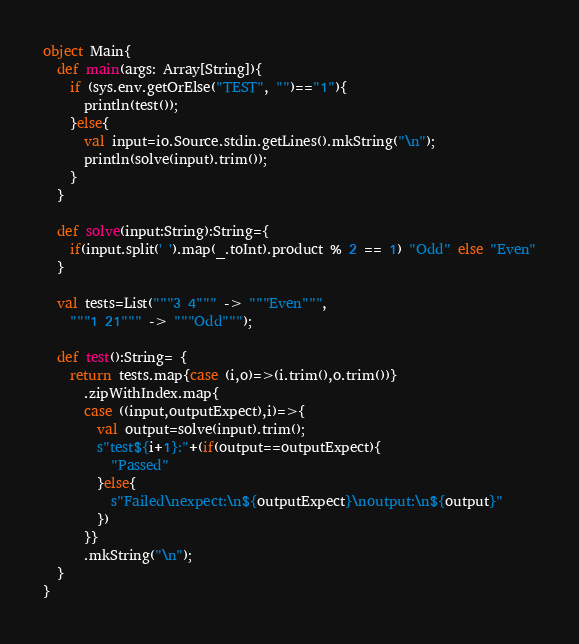<code> <loc_0><loc_0><loc_500><loc_500><_Scala_>object Main{
  def main(args: Array[String]){
    if (sys.env.getOrElse("TEST", "")=="1"){
      println(test());
    }else{
      val input=io.Source.stdin.getLines().mkString("\n");
      println(solve(input).trim());
    }
  }

  def solve(input:String):String={
    if(input.split(' ').map(_.toInt).product % 2 == 1) "Odd" else "Even"
  }

  val tests=List("""3 4""" -> """Even""",
    """1 21""" -> """Odd""");

  def test():String= {
    return tests.map{case (i,o)=>(i.trim(),o.trim())}
      .zipWithIndex.map{
      case ((input,outputExpect),i)=>{
        val output=solve(input).trim();
        s"test${i+1}:"+(if(output==outputExpect){
          "Passed"
        }else{
          s"Failed\nexpect:\n${outputExpect}\noutput:\n${output}"
        })
      }}
      .mkString("\n");
  }
}</code> 